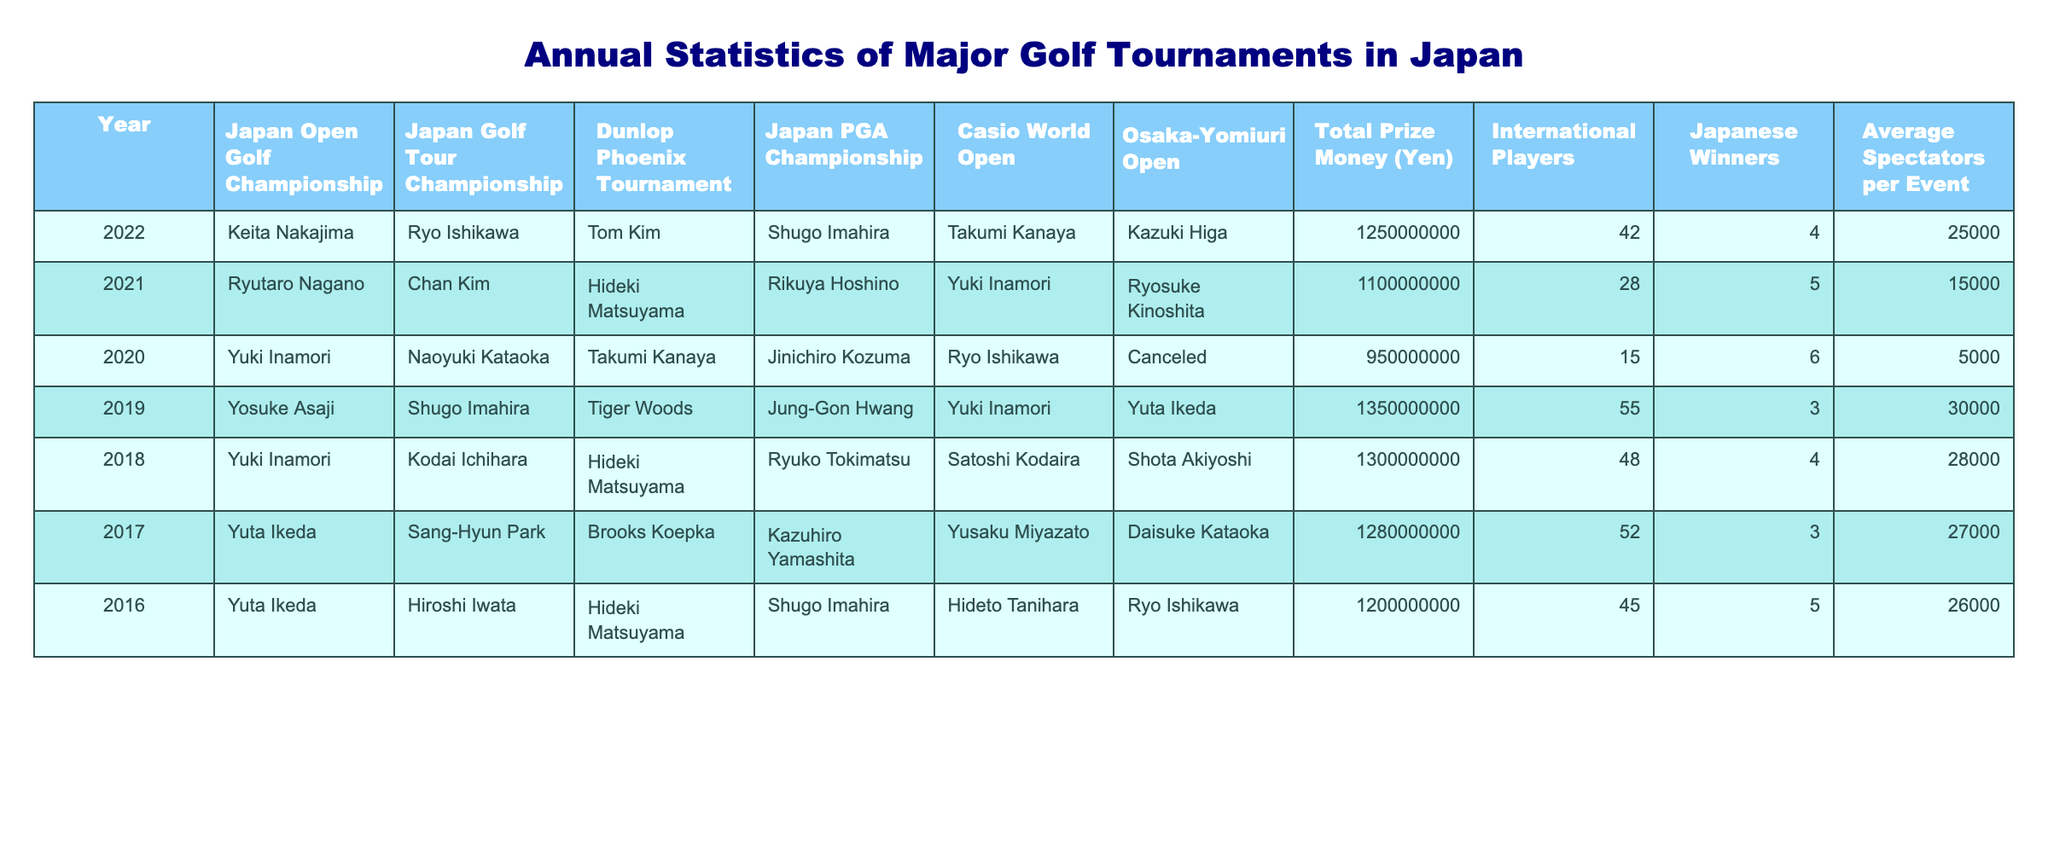What was the total prize money for the Japan Open Golf Championship in 2022? In the table, the total prize money for the Japan Open Golf Championship in 2022 is listed directly. It shows 1,250,000,000 Yen for that year.
Answer: 1,250,000,000 Yen How many international players participated in the Japan PGA Championship in 2021? From the table, we can see that in 2021, the number of international players who participated in the Japan PGA Championship is indicated as 28.
Answer: 28 Which tournament had the highest average spectators per event in 2019? By checking the values in the table for the year 2019, the Osaka-Yomiuri Open had an average of 30,000 spectators, which is the highest when compared to the other tournaments listed for that year.
Answer: Osaka-Yomiuri Open What is the average total prize money across all tournaments from 2016 to 2022? Adding the total prize money from the years 2016 to 2022 results in: (1,200,000,000 + 1,280,000,000 + 1,300,000,000 + 1,350,000,000 + 1,100,000,000 + 1,250,000,000) = 7,480,000,000 Yen. There are 7 years, so dividing gives an average of 7,480,000,000/7 = 1,068,571,428.57 Yen, which rounds to 1,068,571,429 Yen.
Answer: 1,068,571,429 Yen How many Japanese winners were there in the Dunlop Phoenix Tournament between 2020 and 2022? The table indicates that in 2022, there were 4 Japanese winners, and in 2021, there were 5 Japanese winners. In 2020, however, it shows 'Canceled,' meaning there were no winners that year. So, summing them gives 4 + 5 + 0 = 9 Japanese winners across those three years.
Answer: 9 Did the number of international players in the Japan Golf Tour Championship increase from 2021 to 2022? In 2021, the table states there were 28 international players, while in 2022, it shows there were 42 international players. Therefore, the number of international players increased between these two years.
Answer: Yes What was the trend in the average spectators per event from 2016 to 2022? Observing the values for average spectators per event, we have: 26,000 (2016), 27,000 (2017), 28,000 (2018), 30,000 (2019), 15,000 (2021), and 25,000 (2022). The trend shows an overall increase until 2019, a sharp drop in 2021, then a rise again in 2022, indicating fluctuations in attendance over these years.
Answer: Fluctuating trend Which year had the lowest total prize money, and what was the amount? The table shows that in 2020, the total prize money was 950,000,000 Yen, which is the lowest value listed for any of the years presented.
Answer: 950,000,000 Yen How many Japanese winners were there in the Casio World Open in 2021? Referring to the table for the year 2021, we find that the Casio World Open had 1 Japanese winner.
Answer: 1 What was the difference in total prize money between the year with the highest prize money and the year with the lowest prize money? Looking at the total prize money, the highest is 1,350,000,000 Yen (2019) and the lowest is 950,000,000 Yen (2020). Calculating the difference gives: 1,350,000,000 - 950,000,000 = 400,000,000 Yen.
Answer: 400,000,000 Yen 